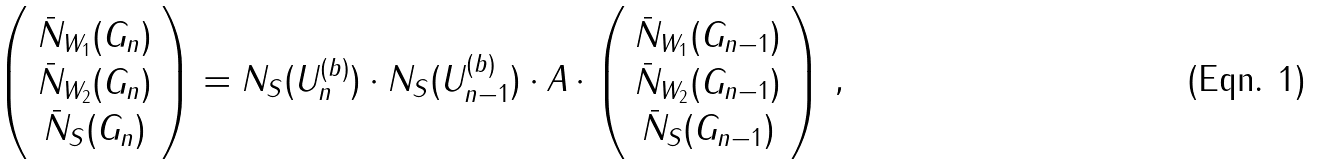Convert formula to latex. <formula><loc_0><loc_0><loc_500><loc_500>\left ( \begin{array} { c } { \bar { N } } _ { W _ { 1 } } ( G _ { n } ) \\ { \bar { N } } _ { W _ { 2 } } ( G _ { n } ) \\ { \bar { N } } _ { S } ( G _ { n } ) \end{array} \right ) = N _ { S } ( U _ { n } ^ { ( b ) } ) \cdot N _ { S } ( U _ { n - 1 } ^ { ( b ) } ) \cdot { A } \cdot \left ( \begin{array} { c } { \bar { N } } _ { W _ { 1 } } ( G _ { n - 1 } ) \\ { \bar { N } } _ { W _ { 2 } } ( G _ { n - 1 } ) \\ { \bar { N } } _ { S } ( G _ { n - 1 } ) \end{array} \right ) \, ,</formula> 